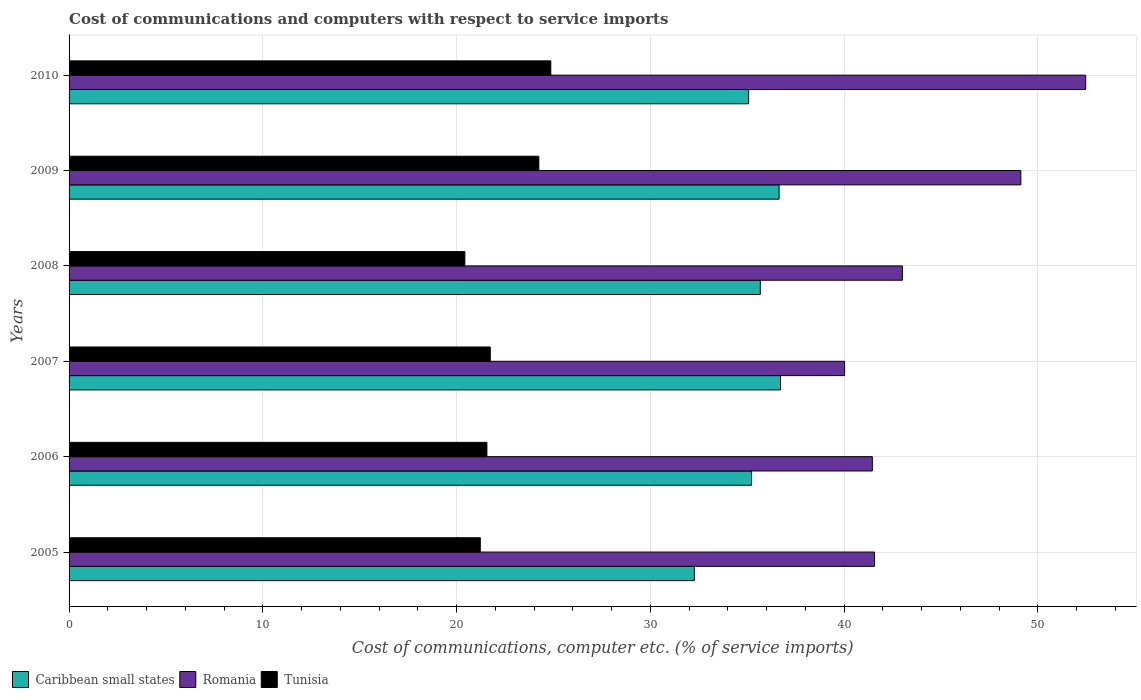How many groups of bars are there?
Offer a terse response. 6. How many bars are there on the 4th tick from the top?
Make the answer very short. 3. What is the label of the 2nd group of bars from the top?
Your answer should be very brief. 2009. What is the cost of communications and computers in Caribbean small states in 2006?
Give a very brief answer. 35.22. Across all years, what is the maximum cost of communications and computers in Caribbean small states?
Your answer should be very brief. 36.71. Across all years, what is the minimum cost of communications and computers in Romania?
Keep it short and to the point. 40.02. In which year was the cost of communications and computers in Romania maximum?
Provide a succinct answer. 2010. In which year was the cost of communications and computers in Tunisia minimum?
Your answer should be compact. 2008. What is the total cost of communications and computers in Caribbean small states in the graph?
Provide a succinct answer. 211.58. What is the difference between the cost of communications and computers in Caribbean small states in 2007 and that in 2009?
Offer a terse response. 0.07. What is the difference between the cost of communications and computers in Tunisia in 2006 and the cost of communications and computers in Romania in 2007?
Give a very brief answer. -18.46. What is the average cost of communications and computers in Tunisia per year?
Your response must be concise. 22.34. In the year 2009, what is the difference between the cost of communications and computers in Tunisia and cost of communications and computers in Caribbean small states?
Give a very brief answer. -12.4. In how many years, is the cost of communications and computers in Tunisia greater than 14 %?
Your answer should be very brief. 6. What is the ratio of the cost of communications and computers in Caribbean small states in 2005 to that in 2006?
Give a very brief answer. 0.92. Is the cost of communications and computers in Romania in 2006 less than that in 2007?
Provide a short and direct response. No. Is the difference between the cost of communications and computers in Tunisia in 2006 and 2010 greater than the difference between the cost of communications and computers in Caribbean small states in 2006 and 2010?
Make the answer very short. No. What is the difference between the highest and the second highest cost of communications and computers in Caribbean small states?
Your answer should be compact. 0.07. What is the difference between the highest and the lowest cost of communications and computers in Tunisia?
Provide a short and direct response. 4.43. Is the sum of the cost of communications and computers in Caribbean small states in 2005 and 2008 greater than the maximum cost of communications and computers in Tunisia across all years?
Provide a succinct answer. Yes. What does the 1st bar from the top in 2006 represents?
Your answer should be compact. Tunisia. What does the 2nd bar from the bottom in 2010 represents?
Offer a terse response. Romania. Is it the case that in every year, the sum of the cost of communications and computers in Romania and cost of communications and computers in Caribbean small states is greater than the cost of communications and computers in Tunisia?
Provide a succinct answer. Yes. How many bars are there?
Offer a very short reply. 18. How many years are there in the graph?
Ensure brevity in your answer.  6. Are the values on the major ticks of X-axis written in scientific E-notation?
Offer a very short reply. No. Does the graph contain grids?
Provide a succinct answer. Yes. Where does the legend appear in the graph?
Your response must be concise. Bottom left. What is the title of the graph?
Keep it short and to the point. Cost of communications and computers with respect to service imports. What is the label or title of the X-axis?
Give a very brief answer. Cost of communications, computer etc. (% of service imports). What is the label or title of the Y-axis?
Offer a terse response. Years. What is the Cost of communications, computer etc. (% of service imports) of Caribbean small states in 2005?
Keep it short and to the point. 32.27. What is the Cost of communications, computer etc. (% of service imports) of Romania in 2005?
Provide a short and direct response. 41.57. What is the Cost of communications, computer etc. (% of service imports) in Tunisia in 2005?
Your response must be concise. 21.22. What is the Cost of communications, computer etc. (% of service imports) in Caribbean small states in 2006?
Offer a terse response. 35.22. What is the Cost of communications, computer etc. (% of service imports) of Romania in 2006?
Provide a short and direct response. 41.45. What is the Cost of communications, computer etc. (% of service imports) in Tunisia in 2006?
Offer a terse response. 21.56. What is the Cost of communications, computer etc. (% of service imports) of Caribbean small states in 2007?
Make the answer very short. 36.71. What is the Cost of communications, computer etc. (% of service imports) in Romania in 2007?
Provide a succinct answer. 40.02. What is the Cost of communications, computer etc. (% of service imports) of Tunisia in 2007?
Keep it short and to the point. 21.74. What is the Cost of communications, computer etc. (% of service imports) in Caribbean small states in 2008?
Offer a very short reply. 35.67. What is the Cost of communications, computer etc. (% of service imports) in Romania in 2008?
Your answer should be very brief. 43. What is the Cost of communications, computer etc. (% of service imports) of Tunisia in 2008?
Your answer should be very brief. 20.42. What is the Cost of communications, computer etc. (% of service imports) of Caribbean small states in 2009?
Ensure brevity in your answer.  36.64. What is the Cost of communications, computer etc. (% of service imports) of Romania in 2009?
Provide a succinct answer. 49.12. What is the Cost of communications, computer etc. (% of service imports) in Tunisia in 2009?
Make the answer very short. 24.24. What is the Cost of communications, computer etc. (% of service imports) in Caribbean small states in 2010?
Your answer should be very brief. 35.07. What is the Cost of communications, computer etc. (% of service imports) of Romania in 2010?
Offer a terse response. 52.46. What is the Cost of communications, computer etc. (% of service imports) in Tunisia in 2010?
Give a very brief answer. 24.86. Across all years, what is the maximum Cost of communications, computer etc. (% of service imports) of Caribbean small states?
Your answer should be compact. 36.71. Across all years, what is the maximum Cost of communications, computer etc. (% of service imports) in Romania?
Offer a very short reply. 52.46. Across all years, what is the maximum Cost of communications, computer etc. (% of service imports) of Tunisia?
Provide a short and direct response. 24.86. Across all years, what is the minimum Cost of communications, computer etc. (% of service imports) of Caribbean small states?
Provide a succinct answer. 32.27. Across all years, what is the minimum Cost of communications, computer etc. (% of service imports) of Romania?
Provide a short and direct response. 40.02. Across all years, what is the minimum Cost of communications, computer etc. (% of service imports) in Tunisia?
Ensure brevity in your answer.  20.42. What is the total Cost of communications, computer etc. (% of service imports) of Caribbean small states in the graph?
Provide a succinct answer. 211.58. What is the total Cost of communications, computer etc. (% of service imports) in Romania in the graph?
Offer a very short reply. 267.62. What is the total Cost of communications, computer etc. (% of service imports) in Tunisia in the graph?
Keep it short and to the point. 134.05. What is the difference between the Cost of communications, computer etc. (% of service imports) of Caribbean small states in 2005 and that in 2006?
Provide a succinct answer. -2.96. What is the difference between the Cost of communications, computer etc. (% of service imports) in Romania in 2005 and that in 2006?
Ensure brevity in your answer.  0.11. What is the difference between the Cost of communications, computer etc. (% of service imports) in Tunisia in 2005 and that in 2006?
Keep it short and to the point. -0.34. What is the difference between the Cost of communications, computer etc. (% of service imports) in Caribbean small states in 2005 and that in 2007?
Keep it short and to the point. -4.45. What is the difference between the Cost of communications, computer etc. (% of service imports) of Romania in 2005 and that in 2007?
Your response must be concise. 1.55. What is the difference between the Cost of communications, computer etc. (% of service imports) in Tunisia in 2005 and that in 2007?
Provide a short and direct response. -0.52. What is the difference between the Cost of communications, computer etc. (% of service imports) of Caribbean small states in 2005 and that in 2008?
Keep it short and to the point. -3.4. What is the difference between the Cost of communications, computer etc. (% of service imports) of Romania in 2005 and that in 2008?
Your response must be concise. -1.44. What is the difference between the Cost of communications, computer etc. (% of service imports) of Tunisia in 2005 and that in 2008?
Ensure brevity in your answer.  0.8. What is the difference between the Cost of communications, computer etc. (% of service imports) in Caribbean small states in 2005 and that in 2009?
Give a very brief answer. -4.37. What is the difference between the Cost of communications, computer etc. (% of service imports) of Romania in 2005 and that in 2009?
Provide a short and direct response. -7.55. What is the difference between the Cost of communications, computer etc. (% of service imports) of Tunisia in 2005 and that in 2009?
Your answer should be compact. -3.02. What is the difference between the Cost of communications, computer etc. (% of service imports) of Caribbean small states in 2005 and that in 2010?
Your answer should be compact. -2.8. What is the difference between the Cost of communications, computer etc. (% of service imports) of Romania in 2005 and that in 2010?
Ensure brevity in your answer.  -10.89. What is the difference between the Cost of communications, computer etc. (% of service imports) in Tunisia in 2005 and that in 2010?
Your response must be concise. -3.64. What is the difference between the Cost of communications, computer etc. (% of service imports) of Caribbean small states in 2006 and that in 2007?
Offer a very short reply. -1.49. What is the difference between the Cost of communications, computer etc. (% of service imports) of Romania in 2006 and that in 2007?
Keep it short and to the point. 1.43. What is the difference between the Cost of communications, computer etc. (% of service imports) of Tunisia in 2006 and that in 2007?
Provide a short and direct response. -0.18. What is the difference between the Cost of communications, computer etc. (% of service imports) of Caribbean small states in 2006 and that in 2008?
Your answer should be compact. -0.45. What is the difference between the Cost of communications, computer etc. (% of service imports) of Romania in 2006 and that in 2008?
Ensure brevity in your answer.  -1.55. What is the difference between the Cost of communications, computer etc. (% of service imports) in Tunisia in 2006 and that in 2008?
Provide a short and direct response. 1.14. What is the difference between the Cost of communications, computer etc. (% of service imports) of Caribbean small states in 2006 and that in 2009?
Give a very brief answer. -1.42. What is the difference between the Cost of communications, computer etc. (% of service imports) of Romania in 2006 and that in 2009?
Your response must be concise. -7.66. What is the difference between the Cost of communications, computer etc. (% of service imports) of Tunisia in 2006 and that in 2009?
Provide a short and direct response. -2.68. What is the difference between the Cost of communications, computer etc. (% of service imports) in Caribbean small states in 2006 and that in 2010?
Make the answer very short. 0.15. What is the difference between the Cost of communications, computer etc. (% of service imports) in Romania in 2006 and that in 2010?
Your answer should be very brief. -11.01. What is the difference between the Cost of communications, computer etc. (% of service imports) of Tunisia in 2006 and that in 2010?
Provide a succinct answer. -3.3. What is the difference between the Cost of communications, computer etc. (% of service imports) of Caribbean small states in 2007 and that in 2008?
Your answer should be compact. 1.04. What is the difference between the Cost of communications, computer etc. (% of service imports) of Romania in 2007 and that in 2008?
Your answer should be compact. -2.98. What is the difference between the Cost of communications, computer etc. (% of service imports) in Tunisia in 2007 and that in 2008?
Your response must be concise. 1.31. What is the difference between the Cost of communications, computer etc. (% of service imports) in Caribbean small states in 2007 and that in 2009?
Your answer should be very brief. 0.07. What is the difference between the Cost of communications, computer etc. (% of service imports) of Romania in 2007 and that in 2009?
Offer a very short reply. -9.1. What is the difference between the Cost of communications, computer etc. (% of service imports) of Tunisia in 2007 and that in 2009?
Provide a short and direct response. -2.5. What is the difference between the Cost of communications, computer etc. (% of service imports) of Caribbean small states in 2007 and that in 2010?
Provide a short and direct response. 1.65. What is the difference between the Cost of communications, computer etc. (% of service imports) in Romania in 2007 and that in 2010?
Your response must be concise. -12.44. What is the difference between the Cost of communications, computer etc. (% of service imports) in Tunisia in 2007 and that in 2010?
Give a very brief answer. -3.12. What is the difference between the Cost of communications, computer etc. (% of service imports) in Caribbean small states in 2008 and that in 2009?
Give a very brief answer. -0.97. What is the difference between the Cost of communications, computer etc. (% of service imports) of Romania in 2008 and that in 2009?
Your response must be concise. -6.11. What is the difference between the Cost of communications, computer etc. (% of service imports) of Tunisia in 2008 and that in 2009?
Make the answer very short. -3.82. What is the difference between the Cost of communications, computer etc. (% of service imports) of Caribbean small states in 2008 and that in 2010?
Offer a very short reply. 0.6. What is the difference between the Cost of communications, computer etc. (% of service imports) of Romania in 2008 and that in 2010?
Offer a very short reply. -9.46. What is the difference between the Cost of communications, computer etc. (% of service imports) of Tunisia in 2008 and that in 2010?
Offer a very short reply. -4.43. What is the difference between the Cost of communications, computer etc. (% of service imports) of Caribbean small states in 2009 and that in 2010?
Offer a terse response. 1.57. What is the difference between the Cost of communications, computer etc. (% of service imports) in Romania in 2009 and that in 2010?
Your answer should be compact. -3.35. What is the difference between the Cost of communications, computer etc. (% of service imports) in Tunisia in 2009 and that in 2010?
Keep it short and to the point. -0.62. What is the difference between the Cost of communications, computer etc. (% of service imports) of Caribbean small states in 2005 and the Cost of communications, computer etc. (% of service imports) of Romania in 2006?
Give a very brief answer. -9.19. What is the difference between the Cost of communications, computer etc. (% of service imports) in Caribbean small states in 2005 and the Cost of communications, computer etc. (% of service imports) in Tunisia in 2006?
Provide a succinct answer. 10.7. What is the difference between the Cost of communications, computer etc. (% of service imports) in Romania in 2005 and the Cost of communications, computer etc. (% of service imports) in Tunisia in 2006?
Give a very brief answer. 20. What is the difference between the Cost of communications, computer etc. (% of service imports) of Caribbean small states in 2005 and the Cost of communications, computer etc. (% of service imports) of Romania in 2007?
Provide a succinct answer. -7.75. What is the difference between the Cost of communications, computer etc. (% of service imports) of Caribbean small states in 2005 and the Cost of communications, computer etc. (% of service imports) of Tunisia in 2007?
Offer a terse response. 10.53. What is the difference between the Cost of communications, computer etc. (% of service imports) of Romania in 2005 and the Cost of communications, computer etc. (% of service imports) of Tunisia in 2007?
Give a very brief answer. 19.83. What is the difference between the Cost of communications, computer etc. (% of service imports) of Caribbean small states in 2005 and the Cost of communications, computer etc. (% of service imports) of Romania in 2008?
Your answer should be very brief. -10.74. What is the difference between the Cost of communications, computer etc. (% of service imports) in Caribbean small states in 2005 and the Cost of communications, computer etc. (% of service imports) in Tunisia in 2008?
Provide a short and direct response. 11.84. What is the difference between the Cost of communications, computer etc. (% of service imports) in Romania in 2005 and the Cost of communications, computer etc. (% of service imports) in Tunisia in 2008?
Provide a succinct answer. 21.14. What is the difference between the Cost of communications, computer etc. (% of service imports) of Caribbean small states in 2005 and the Cost of communications, computer etc. (% of service imports) of Romania in 2009?
Give a very brief answer. -16.85. What is the difference between the Cost of communications, computer etc. (% of service imports) of Caribbean small states in 2005 and the Cost of communications, computer etc. (% of service imports) of Tunisia in 2009?
Your answer should be very brief. 8.02. What is the difference between the Cost of communications, computer etc. (% of service imports) in Romania in 2005 and the Cost of communications, computer etc. (% of service imports) in Tunisia in 2009?
Your answer should be very brief. 17.32. What is the difference between the Cost of communications, computer etc. (% of service imports) in Caribbean small states in 2005 and the Cost of communications, computer etc. (% of service imports) in Romania in 2010?
Offer a very short reply. -20.19. What is the difference between the Cost of communications, computer etc. (% of service imports) in Caribbean small states in 2005 and the Cost of communications, computer etc. (% of service imports) in Tunisia in 2010?
Make the answer very short. 7.41. What is the difference between the Cost of communications, computer etc. (% of service imports) of Romania in 2005 and the Cost of communications, computer etc. (% of service imports) of Tunisia in 2010?
Make the answer very short. 16.71. What is the difference between the Cost of communications, computer etc. (% of service imports) in Caribbean small states in 2006 and the Cost of communications, computer etc. (% of service imports) in Romania in 2007?
Ensure brevity in your answer.  -4.8. What is the difference between the Cost of communications, computer etc. (% of service imports) of Caribbean small states in 2006 and the Cost of communications, computer etc. (% of service imports) of Tunisia in 2007?
Your answer should be compact. 13.48. What is the difference between the Cost of communications, computer etc. (% of service imports) in Romania in 2006 and the Cost of communications, computer etc. (% of service imports) in Tunisia in 2007?
Your response must be concise. 19.72. What is the difference between the Cost of communications, computer etc. (% of service imports) in Caribbean small states in 2006 and the Cost of communications, computer etc. (% of service imports) in Romania in 2008?
Offer a terse response. -7.78. What is the difference between the Cost of communications, computer etc. (% of service imports) of Caribbean small states in 2006 and the Cost of communications, computer etc. (% of service imports) of Tunisia in 2008?
Make the answer very short. 14.8. What is the difference between the Cost of communications, computer etc. (% of service imports) in Romania in 2006 and the Cost of communications, computer etc. (% of service imports) in Tunisia in 2008?
Give a very brief answer. 21.03. What is the difference between the Cost of communications, computer etc. (% of service imports) of Caribbean small states in 2006 and the Cost of communications, computer etc. (% of service imports) of Romania in 2009?
Offer a very short reply. -13.89. What is the difference between the Cost of communications, computer etc. (% of service imports) in Caribbean small states in 2006 and the Cost of communications, computer etc. (% of service imports) in Tunisia in 2009?
Provide a succinct answer. 10.98. What is the difference between the Cost of communications, computer etc. (% of service imports) of Romania in 2006 and the Cost of communications, computer etc. (% of service imports) of Tunisia in 2009?
Offer a very short reply. 17.21. What is the difference between the Cost of communications, computer etc. (% of service imports) of Caribbean small states in 2006 and the Cost of communications, computer etc. (% of service imports) of Romania in 2010?
Your answer should be very brief. -17.24. What is the difference between the Cost of communications, computer etc. (% of service imports) of Caribbean small states in 2006 and the Cost of communications, computer etc. (% of service imports) of Tunisia in 2010?
Your answer should be very brief. 10.36. What is the difference between the Cost of communications, computer etc. (% of service imports) of Romania in 2006 and the Cost of communications, computer etc. (% of service imports) of Tunisia in 2010?
Give a very brief answer. 16.59. What is the difference between the Cost of communications, computer etc. (% of service imports) of Caribbean small states in 2007 and the Cost of communications, computer etc. (% of service imports) of Romania in 2008?
Your answer should be very brief. -6.29. What is the difference between the Cost of communications, computer etc. (% of service imports) in Caribbean small states in 2007 and the Cost of communications, computer etc. (% of service imports) in Tunisia in 2008?
Ensure brevity in your answer.  16.29. What is the difference between the Cost of communications, computer etc. (% of service imports) in Romania in 2007 and the Cost of communications, computer etc. (% of service imports) in Tunisia in 2008?
Offer a terse response. 19.6. What is the difference between the Cost of communications, computer etc. (% of service imports) in Caribbean small states in 2007 and the Cost of communications, computer etc. (% of service imports) in Romania in 2009?
Keep it short and to the point. -12.4. What is the difference between the Cost of communications, computer etc. (% of service imports) in Caribbean small states in 2007 and the Cost of communications, computer etc. (% of service imports) in Tunisia in 2009?
Give a very brief answer. 12.47. What is the difference between the Cost of communications, computer etc. (% of service imports) of Romania in 2007 and the Cost of communications, computer etc. (% of service imports) of Tunisia in 2009?
Provide a succinct answer. 15.78. What is the difference between the Cost of communications, computer etc. (% of service imports) of Caribbean small states in 2007 and the Cost of communications, computer etc. (% of service imports) of Romania in 2010?
Ensure brevity in your answer.  -15.75. What is the difference between the Cost of communications, computer etc. (% of service imports) in Caribbean small states in 2007 and the Cost of communications, computer etc. (% of service imports) in Tunisia in 2010?
Make the answer very short. 11.86. What is the difference between the Cost of communications, computer etc. (% of service imports) of Romania in 2007 and the Cost of communications, computer etc. (% of service imports) of Tunisia in 2010?
Your response must be concise. 15.16. What is the difference between the Cost of communications, computer etc. (% of service imports) of Caribbean small states in 2008 and the Cost of communications, computer etc. (% of service imports) of Romania in 2009?
Provide a succinct answer. -13.45. What is the difference between the Cost of communications, computer etc. (% of service imports) in Caribbean small states in 2008 and the Cost of communications, computer etc. (% of service imports) in Tunisia in 2009?
Offer a very short reply. 11.43. What is the difference between the Cost of communications, computer etc. (% of service imports) of Romania in 2008 and the Cost of communications, computer etc. (% of service imports) of Tunisia in 2009?
Give a very brief answer. 18.76. What is the difference between the Cost of communications, computer etc. (% of service imports) in Caribbean small states in 2008 and the Cost of communications, computer etc. (% of service imports) in Romania in 2010?
Offer a very short reply. -16.79. What is the difference between the Cost of communications, computer etc. (% of service imports) of Caribbean small states in 2008 and the Cost of communications, computer etc. (% of service imports) of Tunisia in 2010?
Provide a short and direct response. 10.81. What is the difference between the Cost of communications, computer etc. (% of service imports) of Romania in 2008 and the Cost of communications, computer etc. (% of service imports) of Tunisia in 2010?
Make the answer very short. 18.15. What is the difference between the Cost of communications, computer etc. (% of service imports) in Caribbean small states in 2009 and the Cost of communications, computer etc. (% of service imports) in Romania in 2010?
Offer a very short reply. -15.82. What is the difference between the Cost of communications, computer etc. (% of service imports) in Caribbean small states in 2009 and the Cost of communications, computer etc. (% of service imports) in Tunisia in 2010?
Give a very brief answer. 11.78. What is the difference between the Cost of communications, computer etc. (% of service imports) of Romania in 2009 and the Cost of communications, computer etc. (% of service imports) of Tunisia in 2010?
Make the answer very short. 24.26. What is the average Cost of communications, computer etc. (% of service imports) in Caribbean small states per year?
Keep it short and to the point. 35.26. What is the average Cost of communications, computer etc. (% of service imports) of Romania per year?
Keep it short and to the point. 44.6. What is the average Cost of communications, computer etc. (% of service imports) in Tunisia per year?
Ensure brevity in your answer.  22.34. In the year 2005, what is the difference between the Cost of communications, computer etc. (% of service imports) of Caribbean small states and Cost of communications, computer etc. (% of service imports) of Romania?
Your response must be concise. -9.3. In the year 2005, what is the difference between the Cost of communications, computer etc. (% of service imports) in Caribbean small states and Cost of communications, computer etc. (% of service imports) in Tunisia?
Your answer should be very brief. 11.04. In the year 2005, what is the difference between the Cost of communications, computer etc. (% of service imports) of Romania and Cost of communications, computer etc. (% of service imports) of Tunisia?
Make the answer very short. 20.34. In the year 2006, what is the difference between the Cost of communications, computer etc. (% of service imports) of Caribbean small states and Cost of communications, computer etc. (% of service imports) of Romania?
Keep it short and to the point. -6.23. In the year 2006, what is the difference between the Cost of communications, computer etc. (% of service imports) in Caribbean small states and Cost of communications, computer etc. (% of service imports) in Tunisia?
Give a very brief answer. 13.66. In the year 2006, what is the difference between the Cost of communications, computer etc. (% of service imports) in Romania and Cost of communications, computer etc. (% of service imports) in Tunisia?
Give a very brief answer. 19.89. In the year 2007, what is the difference between the Cost of communications, computer etc. (% of service imports) of Caribbean small states and Cost of communications, computer etc. (% of service imports) of Romania?
Your answer should be very brief. -3.31. In the year 2007, what is the difference between the Cost of communications, computer etc. (% of service imports) in Caribbean small states and Cost of communications, computer etc. (% of service imports) in Tunisia?
Your response must be concise. 14.98. In the year 2007, what is the difference between the Cost of communications, computer etc. (% of service imports) of Romania and Cost of communications, computer etc. (% of service imports) of Tunisia?
Make the answer very short. 18.28. In the year 2008, what is the difference between the Cost of communications, computer etc. (% of service imports) of Caribbean small states and Cost of communications, computer etc. (% of service imports) of Romania?
Offer a terse response. -7.33. In the year 2008, what is the difference between the Cost of communications, computer etc. (% of service imports) of Caribbean small states and Cost of communications, computer etc. (% of service imports) of Tunisia?
Ensure brevity in your answer.  15.25. In the year 2008, what is the difference between the Cost of communications, computer etc. (% of service imports) in Romania and Cost of communications, computer etc. (% of service imports) in Tunisia?
Keep it short and to the point. 22.58. In the year 2009, what is the difference between the Cost of communications, computer etc. (% of service imports) of Caribbean small states and Cost of communications, computer etc. (% of service imports) of Romania?
Make the answer very short. -12.47. In the year 2009, what is the difference between the Cost of communications, computer etc. (% of service imports) in Caribbean small states and Cost of communications, computer etc. (% of service imports) in Tunisia?
Provide a succinct answer. 12.4. In the year 2009, what is the difference between the Cost of communications, computer etc. (% of service imports) of Romania and Cost of communications, computer etc. (% of service imports) of Tunisia?
Make the answer very short. 24.87. In the year 2010, what is the difference between the Cost of communications, computer etc. (% of service imports) in Caribbean small states and Cost of communications, computer etc. (% of service imports) in Romania?
Give a very brief answer. -17.39. In the year 2010, what is the difference between the Cost of communications, computer etc. (% of service imports) of Caribbean small states and Cost of communications, computer etc. (% of service imports) of Tunisia?
Offer a very short reply. 10.21. In the year 2010, what is the difference between the Cost of communications, computer etc. (% of service imports) of Romania and Cost of communications, computer etc. (% of service imports) of Tunisia?
Offer a terse response. 27.6. What is the ratio of the Cost of communications, computer etc. (% of service imports) of Caribbean small states in 2005 to that in 2006?
Provide a succinct answer. 0.92. What is the ratio of the Cost of communications, computer etc. (% of service imports) in Romania in 2005 to that in 2006?
Give a very brief answer. 1. What is the ratio of the Cost of communications, computer etc. (% of service imports) in Tunisia in 2005 to that in 2006?
Offer a very short reply. 0.98. What is the ratio of the Cost of communications, computer etc. (% of service imports) in Caribbean small states in 2005 to that in 2007?
Provide a short and direct response. 0.88. What is the ratio of the Cost of communications, computer etc. (% of service imports) of Romania in 2005 to that in 2007?
Offer a very short reply. 1.04. What is the ratio of the Cost of communications, computer etc. (% of service imports) of Tunisia in 2005 to that in 2007?
Keep it short and to the point. 0.98. What is the ratio of the Cost of communications, computer etc. (% of service imports) in Caribbean small states in 2005 to that in 2008?
Give a very brief answer. 0.9. What is the ratio of the Cost of communications, computer etc. (% of service imports) of Romania in 2005 to that in 2008?
Provide a short and direct response. 0.97. What is the ratio of the Cost of communications, computer etc. (% of service imports) in Tunisia in 2005 to that in 2008?
Your answer should be very brief. 1.04. What is the ratio of the Cost of communications, computer etc. (% of service imports) of Caribbean small states in 2005 to that in 2009?
Your answer should be compact. 0.88. What is the ratio of the Cost of communications, computer etc. (% of service imports) of Romania in 2005 to that in 2009?
Provide a succinct answer. 0.85. What is the ratio of the Cost of communications, computer etc. (% of service imports) in Tunisia in 2005 to that in 2009?
Give a very brief answer. 0.88. What is the ratio of the Cost of communications, computer etc. (% of service imports) of Caribbean small states in 2005 to that in 2010?
Offer a very short reply. 0.92. What is the ratio of the Cost of communications, computer etc. (% of service imports) of Romania in 2005 to that in 2010?
Make the answer very short. 0.79. What is the ratio of the Cost of communications, computer etc. (% of service imports) in Tunisia in 2005 to that in 2010?
Offer a very short reply. 0.85. What is the ratio of the Cost of communications, computer etc. (% of service imports) in Caribbean small states in 2006 to that in 2007?
Keep it short and to the point. 0.96. What is the ratio of the Cost of communications, computer etc. (% of service imports) in Romania in 2006 to that in 2007?
Your answer should be compact. 1.04. What is the ratio of the Cost of communications, computer etc. (% of service imports) in Tunisia in 2006 to that in 2007?
Your response must be concise. 0.99. What is the ratio of the Cost of communications, computer etc. (% of service imports) of Caribbean small states in 2006 to that in 2008?
Ensure brevity in your answer.  0.99. What is the ratio of the Cost of communications, computer etc. (% of service imports) in Romania in 2006 to that in 2008?
Offer a terse response. 0.96. What is the ratio of the Cost of communications, computer etc. (% of service imports) in Tunisia in 2006 to that in 2008?
Your response must be concise. 1.06. What is the ratio of the Cost of communications, computer etc. (% of service imports) in Caribbean small states in 2006 to that in 2009?
Your response must be concise. 0.96. What is the ratio of the Cost of communications, computer etc. (% of service imports) of Romania in 2006 to that in 2009?
Offer a very short reply. 0.84. What is the ratio of the Cost of communications, computer etc. (% of service imports) of Tunisia in 2006 to that in 2009?
Ensure brevity in your answer.  0.89. What is the ratio of the Cost of communications, computer etc. (% of service imports) of Romania in 2006 to that in 2010?
Provide a succinct answer. 0.79. What is the ratio of the Cost of communications, computer etc. (% of service imports) in Tunisia in 2006 to that in 2010?
Offer a very short reply. 0.87. What is the ratio of the Cost of communications, computer etc. (% of service imports) of Caribbean small states in 2007 to that in 2008?
Your answer should be very brief. 1.03. What is the ratio of the Cost of communications, computer etc. (% of service imports) in Romania in 2007 to that in 2008?
Provide a short and direct response. 0.93. What is the ratio of the Cost of communications, computer etc. (% of service imports) of Tunisia in 2007 to that in 2008?
Make the answer very short. 1.06. What is the ratio of the Cost of communications, computer etc. (% of service imports) of Caribbean small states in 2007 to that in 2009?
Keep it short and to the point. 1. What is the ratio of the Cost of communications, computer etc. (% of service imports) of Romania in 2007 to that in 2009?
Provide a succinct answer. 0.81. What is the ratio of the Cost of communications, computer etc. (% of service imports) in Tunisia in 2007 to that in 2009?
Ensure brevity in your answer.  0.9. What is the ratio of the Cost of communications, computer etc. (% of service imports) in Caribbean small states in 2007 to that in 2010?
Provide a short and direct response. 1.05. What is the ratio of the Cost of communications, computer etc. (% of service imports) of Romania in 2007 to that in 2010?
Your answer should be very brief. 0.76. What is the ratio of the Cost of communications, computer etc. (% of service imports) of Tunisia in 2007 to that in 2010?
Your response must be concise. 0.87. What is the ratio of the Cost of communications, computer etc. (% of service imports) of Caribbean small states in 2008 to that in 2009?
Your answer should be compact. 0.97. What is the ratio of the Cost of communications, computer etc. (% of service imports) in Romania in 2008 to that in 2009?
Your answer should be compact. 0.88. What is the ratio of the Cost of communications, computer etc. (% of service imports) in Tunisia in 2008 to that in 2009?
Offer a terse response. 0.84. What is the ratio of the Cost of communications, computer etc. (% of service imports) of Caribbean small states in 2008 to that in 2010?
Your answer should be very brief. 1.02. What is the ratio of the Cost of communications, computer etc. (% of service imports) of Romania in 2008 to that in 2010?
Provide a succinct answer. 0.82. What is the ratio of the Cost of communications, computer etc. (% of service imports) of Tunisia in 2008 to that in 2010?
Your answer should be compact. 0.82. What is the ratio of the Cost of communications, computer etc. (% of service imports) in Caribbean small states in 2009 to that in 2010?
Give a very brief answer. 1.04. What is the ratio of the Cost of communications, computer etc. (% of service imports) of Romania in 2009 to that in 2010?
Provide a succinct answer. 0.94. What is the ratio of the Cost of communications, computer etc. (% of service imports) in Tunisia in 2009 to that in 2010?
Give a very brief answer. 0.98. What is the difference between the highest and the second highest Cost of communications, computer etc. (% of service imports) of Caribbean small states?
Give a very brief answer. 0.07. What is the difference between the highest and the second highest Cost of communications, computer etc. (% of service imports) of Romania?
Your answer should be compact. 3.35. What is the difference between the highest and the second highest Cost of communications, computer etc. (% of service imports) of Tunisia?
Offer a terse response. 0.62. What is the difference between the highest and the lowest Cost of communications, computer etc. (% of service imports) of Caribbean small states?
Make the answer very short. 4.45. What is the difference between the highest and the lowest Cost of communications, computer etc. (% of service imports) in Romania?
Provide a succinct answer. 12.44. What is the difference between the highest and the lowest Cost of communications, computer etc. (% of service imports) of Tunisia?
Give a very brief answer. 4.43. 